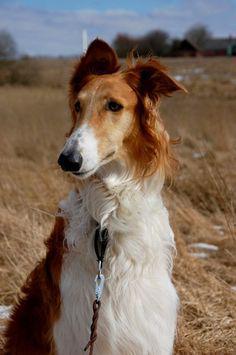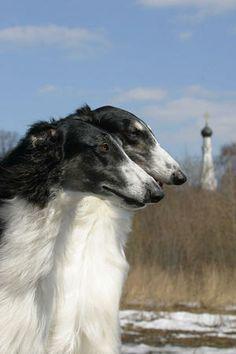The first image is the image on the left, the second image is the image on the right. Analyze the images presented: Is the assertion "Two dogs are playing with each other in one image." valid? Answer yes or no. No. 